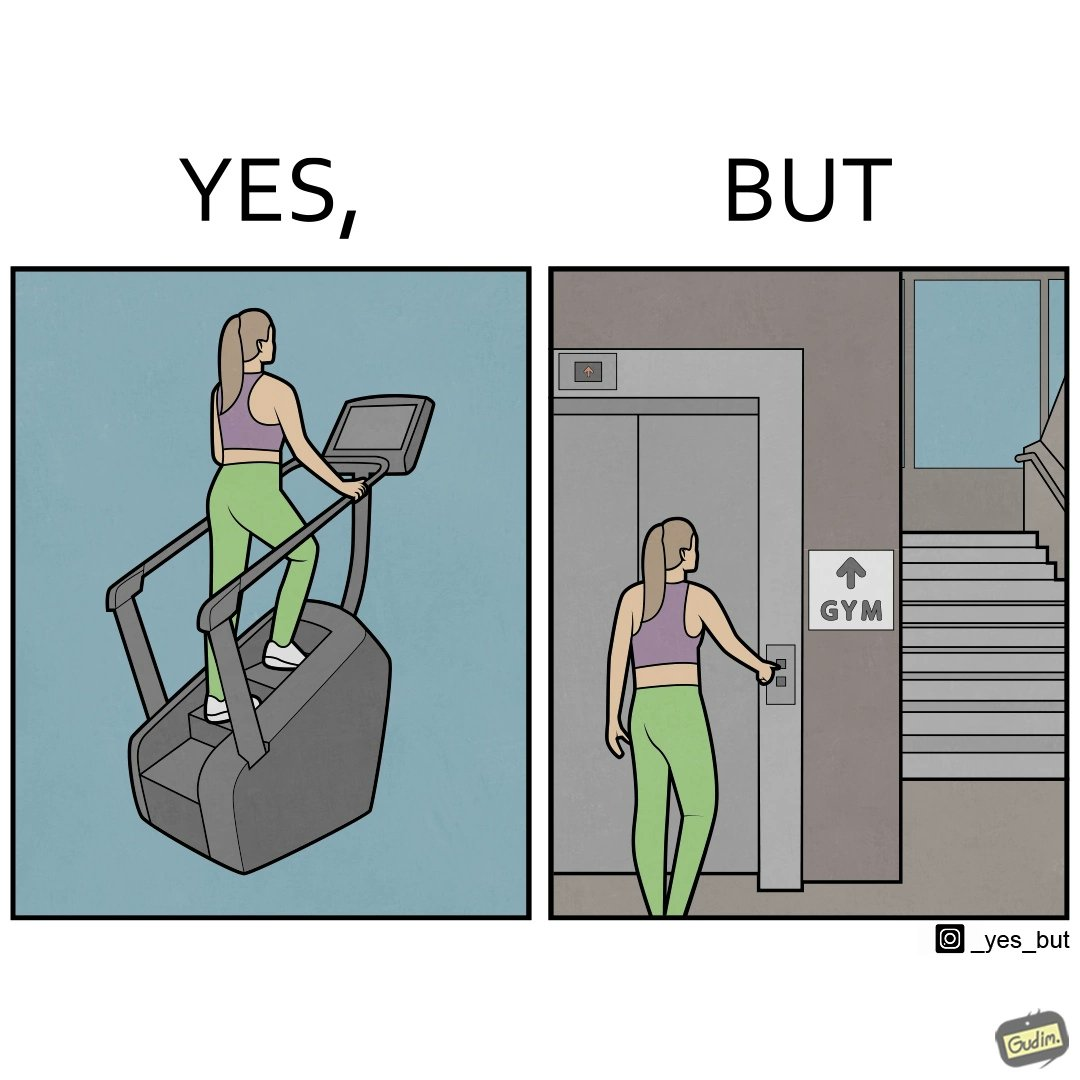Explain why this image is satirical. The image is ironic, because in the left image a woman is seen using the stair climber machine at the gym but the same woman is not ready to climb up some stairs for going to the gym and is calling for the lift 